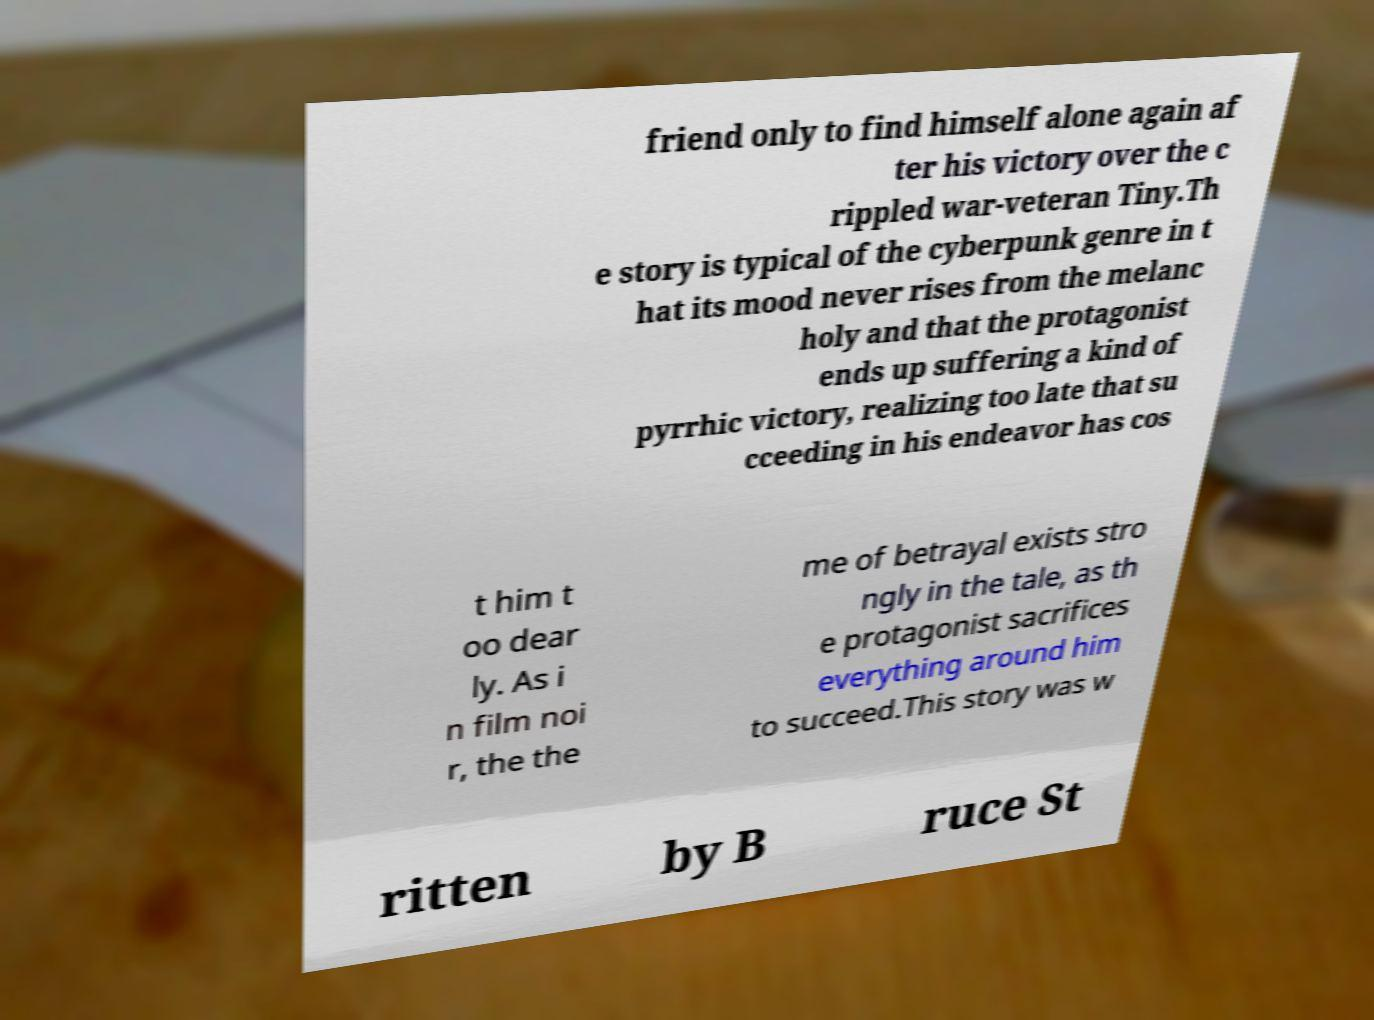What messages or text are displayed in this image? I need them in a readable, typed format. friend only to find himself alone again af ter his victory over the c rippled war-veteran Tiny.Th e story is typical of the cyberpunk genre in t hat its mood never rises from the melanc holy and that the protagonist ends up suffering a kind of pyrrhic victory, realizing too late that su cceeding in his endeavor has cos t him t oo dear ly. As i n film noi r, the the me of betrayal exists stro ngly in the tale, as th e protagonist sacrifices everything around him to succeed.This story was w ritten by B ruce St 